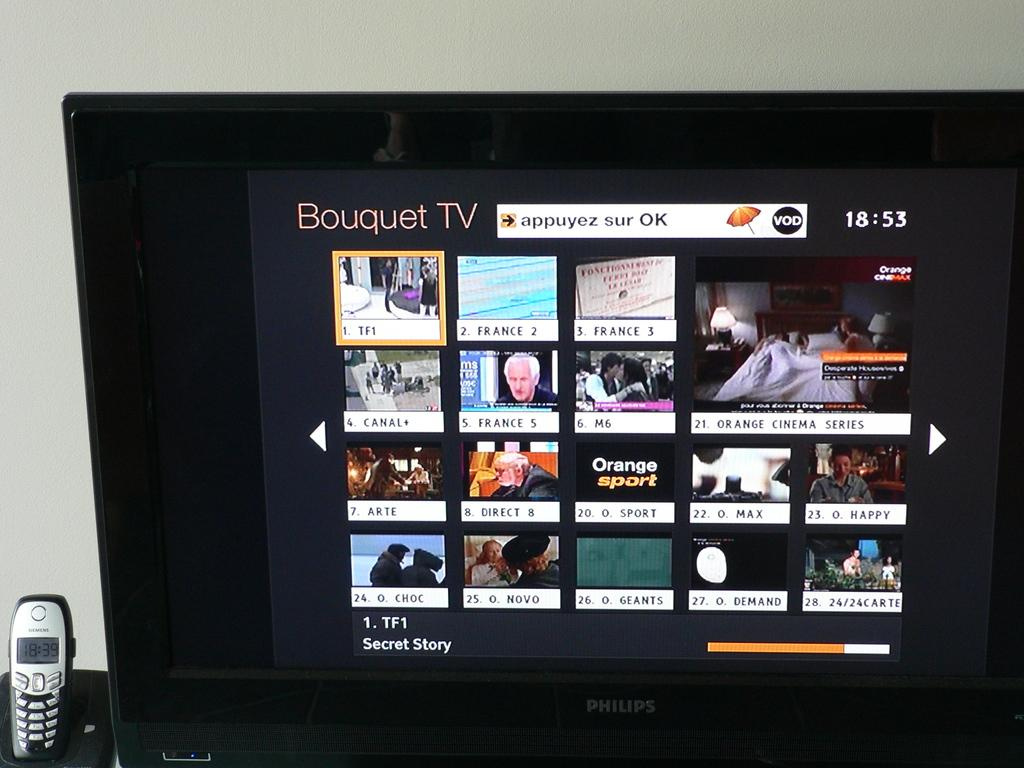<image>
Write a terse but informative summary of the picture. A phillips TV shows a channel called Bouquet TV with their programming. 